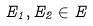<formula> <loc_0><loc_0><loc_500><loc_500>E _ { 1 } , E _ { 2 } \in E</formula> 